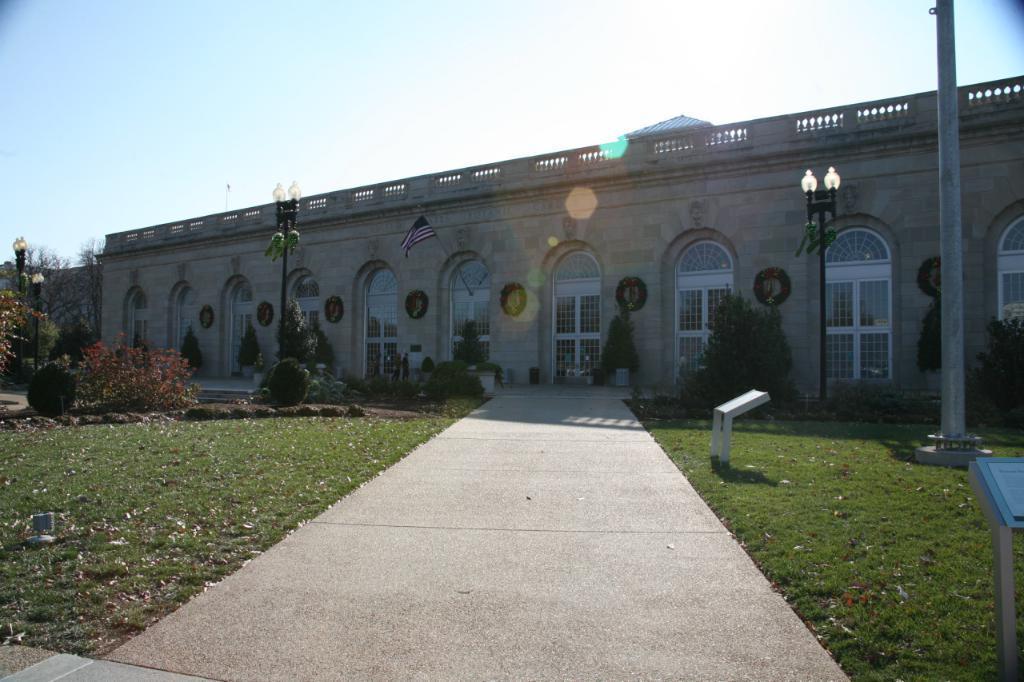Can you describe this image briefly? In the middle of this image there is a building. At the bottom there is a driveway. On both sides of it I can see the grass. On the right side there is a pole and a table. On the left side there are few plants and light poles. In front of this building there are few plants. At the top of the image I can see the sky. 